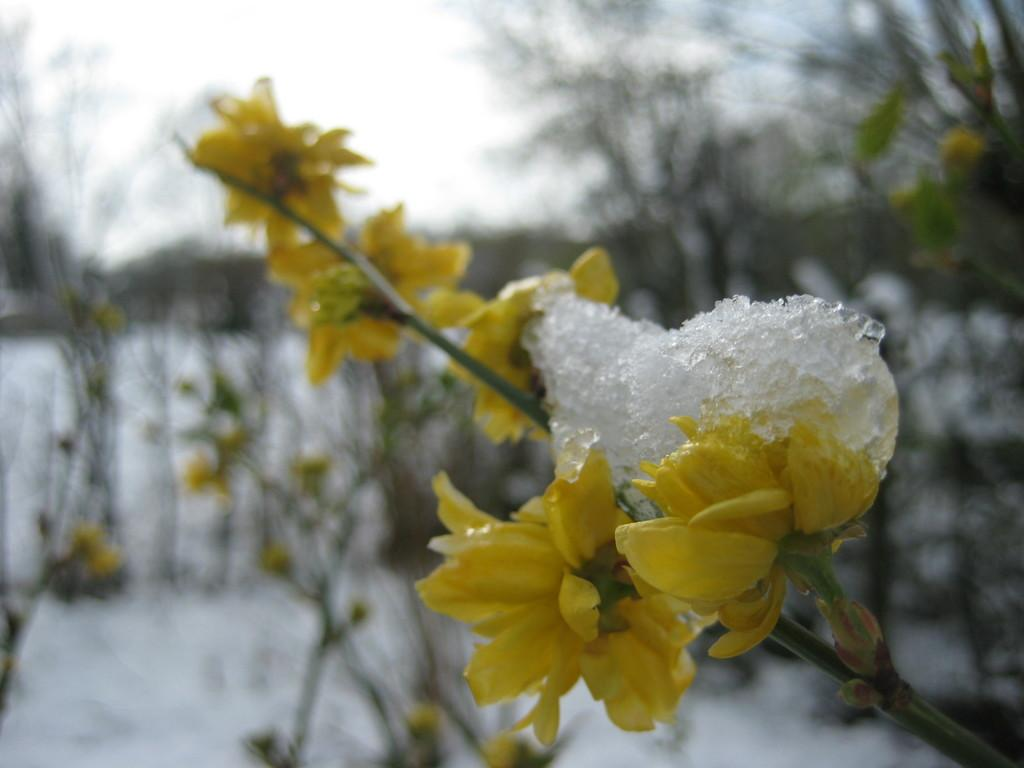What type of flowers can be seen in the image? There are yellow flowers in the image. What is covering the flowers? Snow is covering the flowers in the image. Can you describe the background of the image? The background of the image is blurred. What color is the crayon used to draw the flowers in the image? There is no crayon or drawing present in the image; it features real yellow flowers with snow on them. 